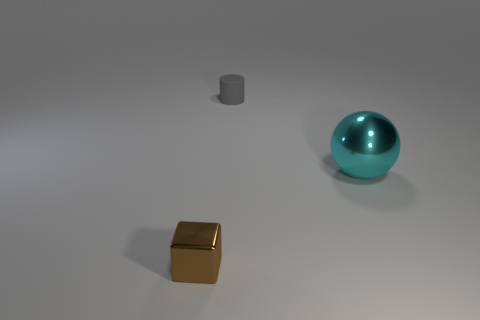Are there any other things that are the same material as the small gray cylinder?
Your response must be concise. No. Are there any other things that have the same size as the cyan thing?
Provide a succinct answer. No. What is the material of the other thing that is the same size as the brown shiny thing?
Provide a succinct answer. Rubber. Are there any gray cylinders of the same size as the ball?
Your answer should be very brief. No. There is a rubber thing that is the same size as the brown shiny block; what shape is it?
Your response must be concise. Cylinder. What number of other objects are the same color as the tiny matte cylinder?
Offer a very short reply. 0. There is a object that is both in front of the tiny matte cylinder and behind the small brown metallic block; what is its shape?
Offer a terse response. Sphere. Are there any large cyan things that are to the left of the small object that is behind the metallic object in front of the cyan ball?
Provide a succinct answer. No. How many other objects are the same material as the cube?
Keep it short and to the point. 1. How many brown shiny things are there?
Give a very brief answer. 1. 